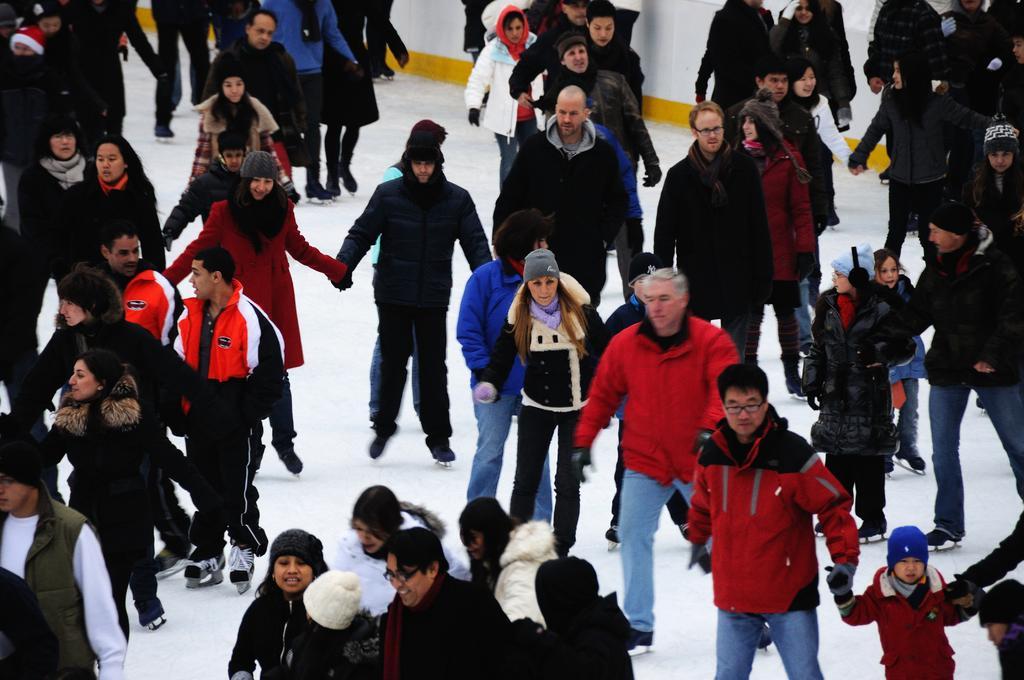Can you describe this image briefly? In the picture I can see a group of people and they are skating on the ice surface. I can see most of them wearing the jacket and a few people wearing the monkey cap on their head. 